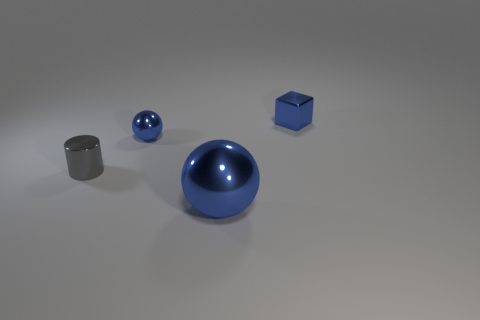Can you determine the lighting source in the scene? The lighting in the scene seems to be coming from above, likely from an environment light or a softbox, given the soft shadows and the way light is diffusely reflecting off the objects, creating a gentle gradient on the surface they rest on. 